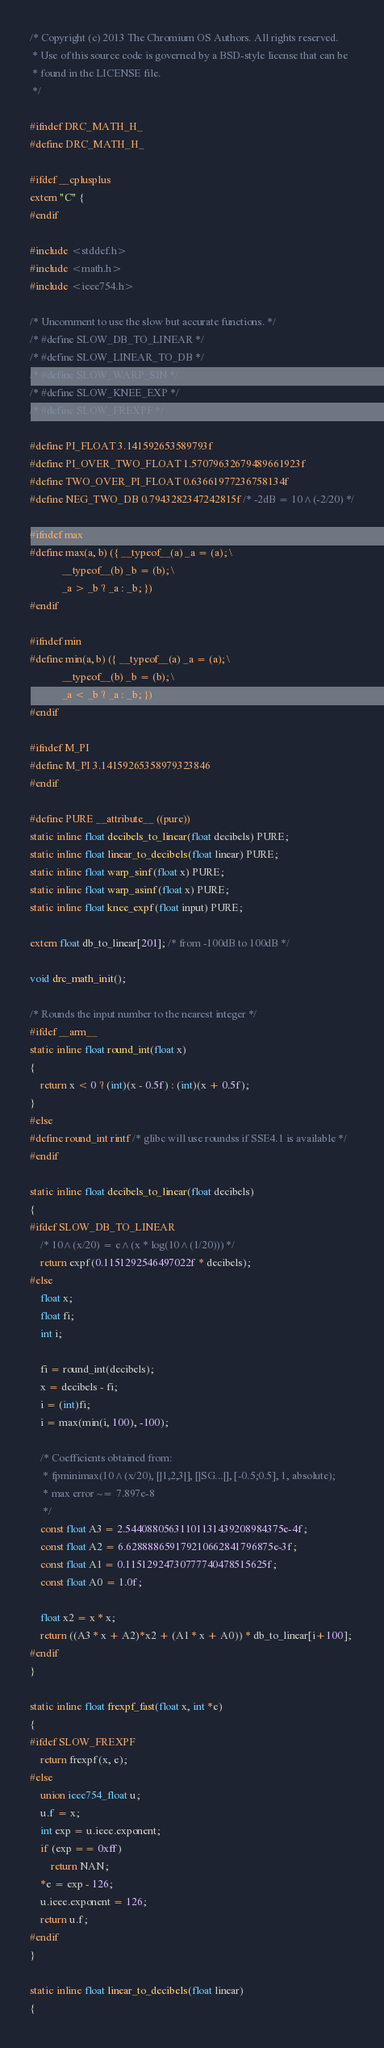<code> <loc_0><loc_0><loc_500><loc_500><_C_>/* Copyright (c) 2013 The Chromium OS Authors. All rights reserved.
 * Use of this source code is governed by a BSD-style license that can be
 * found in the LICENSE file.
 */

#ifndef DRC_MATH_H_
#define DRC_MATH_H_

#ifdef __cplusplus
extern "C" {
#endif

#include <stddef.h>
#include <math.h>
#include <ieee754.h>

/* Uncomment to use the slow but accurate functions. */
/* #define SLOW_DB_TO_LINEAR */
/* #define SLOW_LINEAR_TO_DB */
/* #define SLOW_WARP_SIN */
/* #define SLOW_KNEE_EXP */
/* #define SLOW_FREXPF */

#define PI_FLOAT 3.141592653589793f
#define PI_OVER_TWO_FLOAT 1.57079632679489661923f
#define TWO_OVER_PI_FLOAT 0.63661977236758134f
#define NEG_TWO_DB 0.7943282347242815f /* -2dB = 10^(-2/20) */

#ifndef max
#define max(a, b) ({ __typeof__(a) _a = (a);	\
			__typeof__(b) _b = (b);	\
			_a > _b ? _a : _b; })
#endif

#ifndef min
#define min(a, b) ({ __typeof__(a) _a = (a);	\
			__typeof__(b) _b = (b);	\
			_a < _b ? _a : _b; })
#endif

#ifndef M_PI
#define M_PI 3.14159265358979323846
#endif

#define PURE __attribute__ ((pure))
static inline float decibels_to_linear(float decibels) PURE;
static inline float linear_to_decibels(float linear) PURE;
static inline float warp_sinf(float x) PURE;
static inline float warp_asinf(float x) PURE;
static inline float knee_expf(float input) PURE;

extern float db_to_linear[201]; /* from -100dB to 100dB */

void drc_math_init();

/* Rounds the input number to the nearest integer */
#ifdef __arm__
static inline float round_int(float x)
{
	return x < 0 ? (int)(x - 0.5f) : (int)(x + 0.5f);
}
#else
#define round_int rintf /* glibc will use roundss if SSE4.1 is available */
#endif

static inline float decibels_to_linear(float decibels)
{
#ifdef SLOW_DB_TO_LINEAR
	/* 10^(x/20) = e^(x * log(10^(1/20))) */
	return expf(0.1151292546497022f * decibels);
#else
	float x;
	float fi;
	int i;

	fi = round_int(decibels);
	x = decibels - fi;
	i = (int)fi;
	i = max(min(i, 100), -100);

	/* Coefficients obtained from:
	 * fpminimax(10^(x/20), [|1,2,3|], [|SG...|], [-0.5;0.5], 1, absolute);
	 * max error ~= 7.897e-8
	 */
	const float A3 = 2.54408805631101131439208984375e-4f;
	const float A2 = 6.628888659179210662841796875e-3f;
	const float A1 = 0.11512924730777740478515625f;
	const float A0 = 1.0f;

	float x2 = x * x;
	return ((A3 * x + A2)*x2 + (A1 * x + A0)) * db_to_linear[i+100];
#endif
}

static inline float frexpf_fast(float x, int *e)
{
#ifdef SLOW_FREXPF
	return frexpf(x, e);
#else
	union ieee754_float u;
	u.f = x;
	int exp = u.ieee.exponent;
	if (exp == 0xff)
		return NAN;
	*e = exp - 126;
	u.ieee.exponent = 126;
	return u.f;
#endif
}

static inline float linear_to_decibels(float linear)
{</code> 